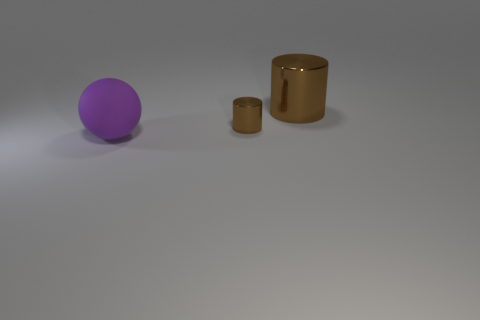There is a big object on the right side of the large purple object; how many large purple spheres are in front of it?
Keep it short and to the point. 1. Are there any other things that are the same material as the purple thing?
Make the answer very short. No. How many objects are cylinders that are behind the tiny brown cylinder or small brown metal things?
Offer a very short reply. 2. How big is the brown metallic cylinder in front of the large metal cylinder?
Your answer should be very brief. Small. What is the tiny object made of?
Your response must be concise. Metal. What is the shape of the big thing that is behind the big object that is in front of the large metallic cylinder?
Make the answer very short. Cylinder. What number of other objects are there of the same shape as the big purple thing?
Ensure brevity in your answer.  0. There is a large brown metallic thing; are there any tiny brown metal objects to the right of it?
Keep it short and to the point. No. The tiny shiny cylinder has what color?
Make the answer very short. Brown. Do the sphere and the large thing behind the purple matte ball have the same color?
Keep it short and to the point. No. 